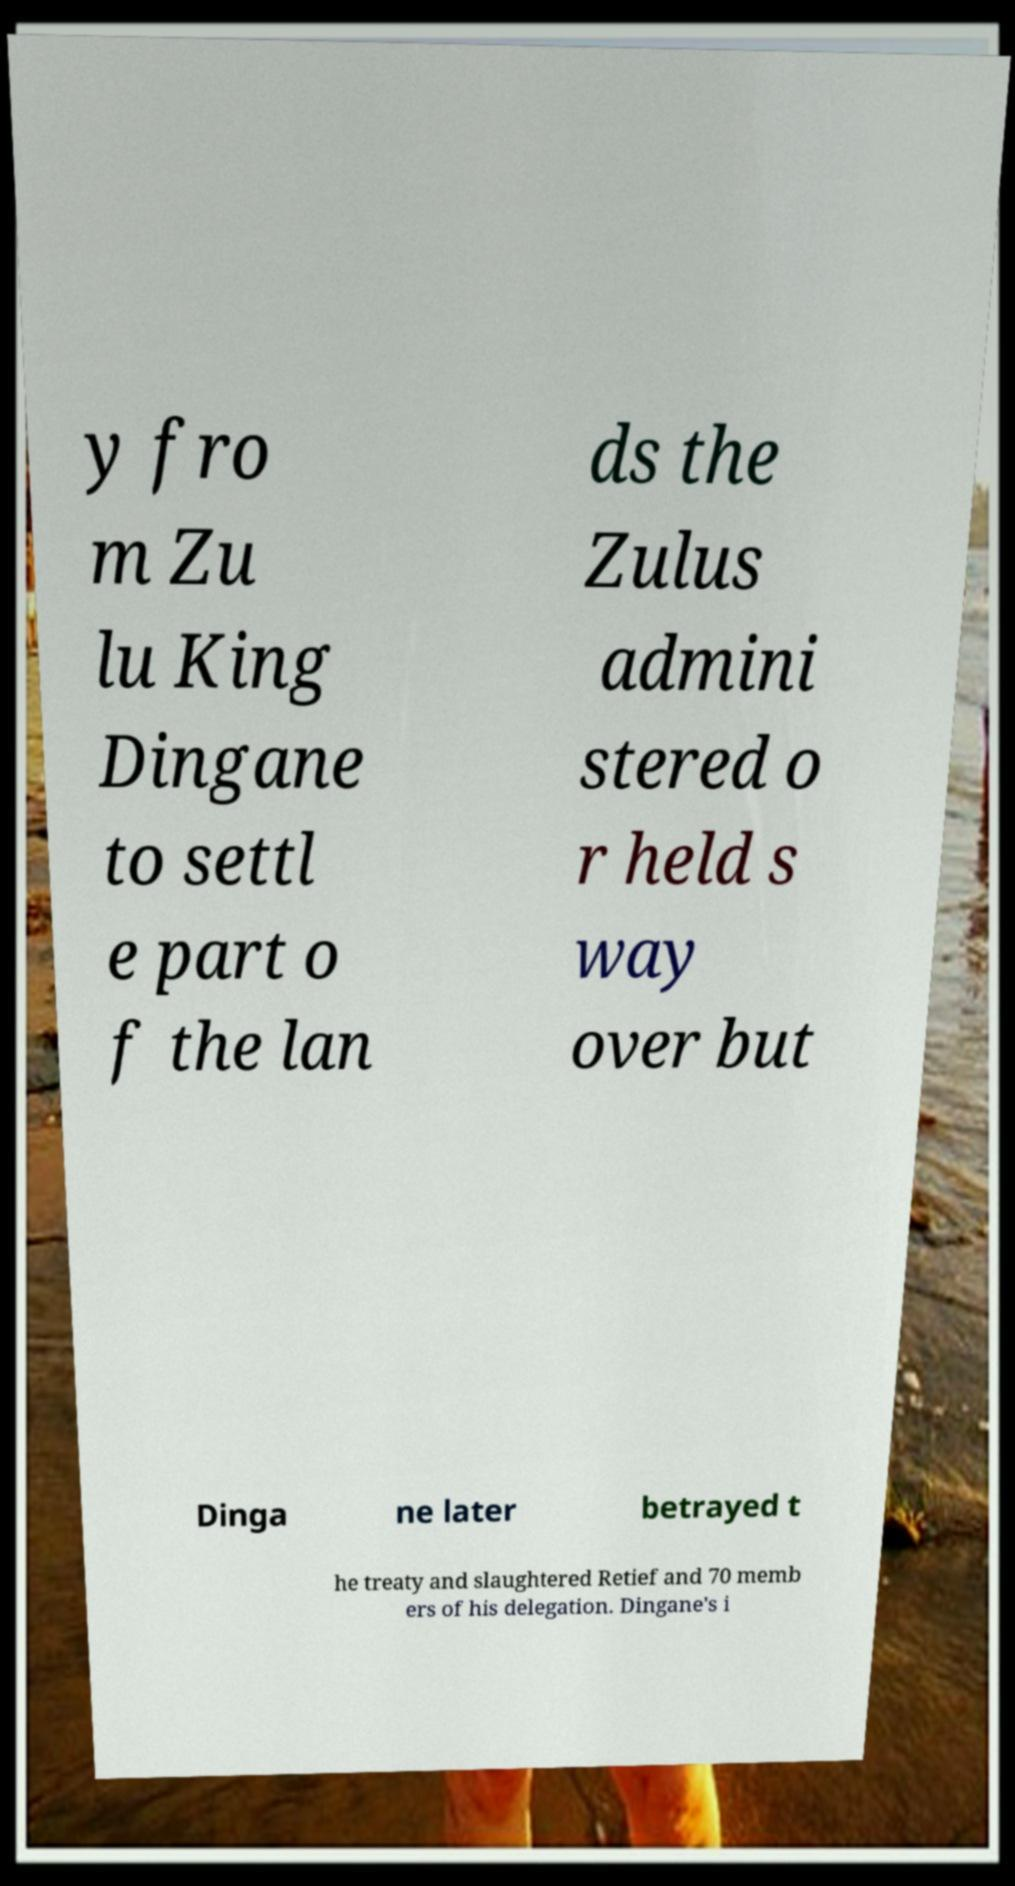Could you extract and type out the text from this image? y fro m Zu lu King Dingane to settl e part o f the lan ds the Zulus admini stered o r held s way over but Dinga ne later betrayed t he treaty and slaughtered Retief and 70 memb ers of his delegation. Dingane's i 